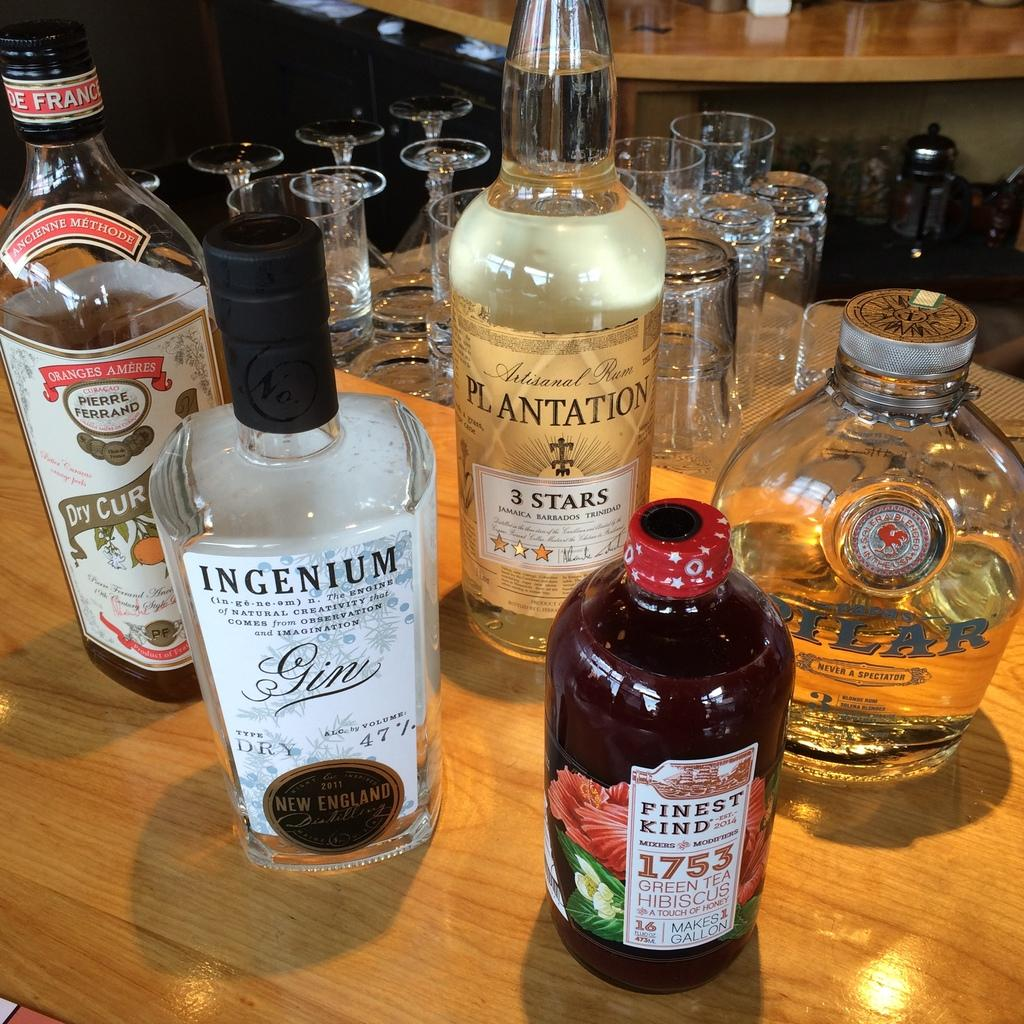<image>
Summarize the visual content of the image. several jars of liquor on a table including Ingenium and Plantation 